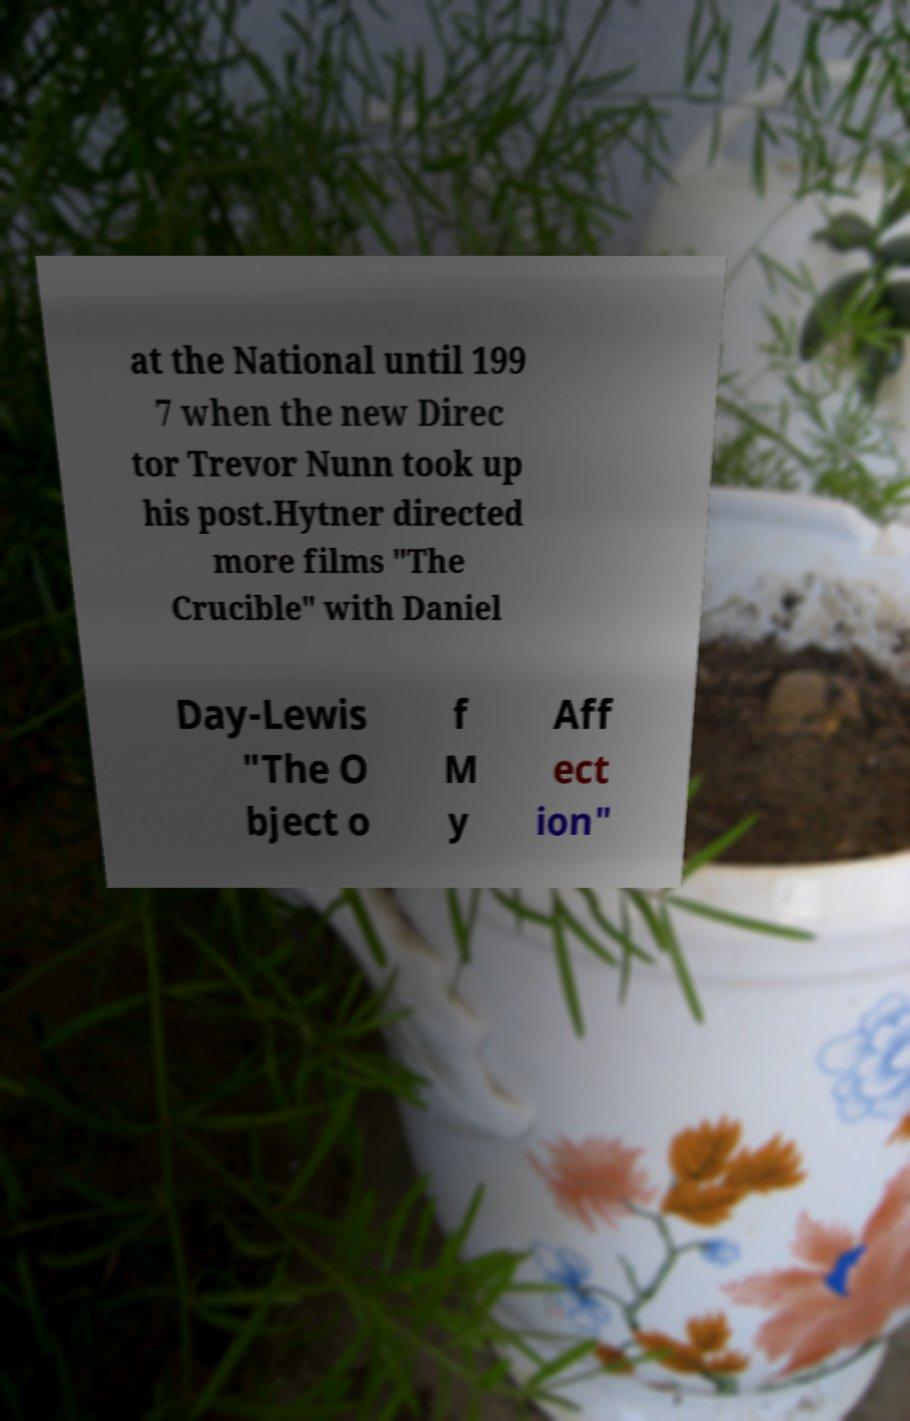I need the written content from this picture converted into text. Can you do that? at the National until 199 7 when the new Direc tor Trevor Nunn took up his post.Hytner directed more films "The Crucible" with Daniel Day-Lewis "The O bject o f M y Aff ect ion" 